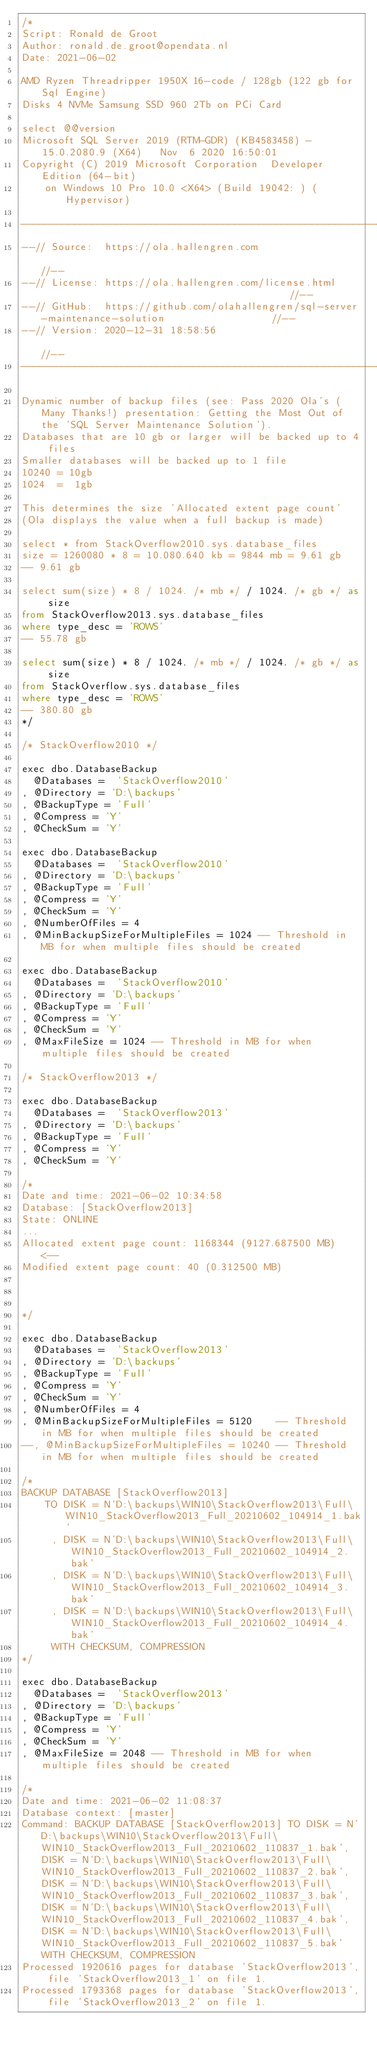Convert code to text. <code><loc_0><loc_0><loc_500><loc_500><_SQL_>/* 
Script: Ronald de Groot 
Author: ronald.de.groot@opendata.nl
Date: 2021-06-02

AMD Ryzen Threadripper 1950X 16-code / 128gb (122 gb for Sql Engine)
Disks 4 NVMe Samsung SSD 960 2Tb on PCi Card

select @@version
Microsoft SQL Server 2019 (RTM-GDR) (KB4583458) - 15.0.2080.9 (X64)   Nov  6 2020 16:50:01   
Copyright (C) 2019 Microsoft Corporation  Developer Edition (64-bit) 
	on Windows 10 Pro 10.0 <X64> (Build 19042: ) (Hypervisor) 

----------------------------------------------------------------------------------------------------
--// Source:  https://ola.hallengren.com                                                        //--
--// License: https://ola.hallengren.com/license.html                                           //--
--// GitHub:  https://github.com/olahallengren/sql-server-maintenance-solution                  //--
--// Version: 2020-12-31 18:58:56                                                               //--
----------------------------------------------------------------------------------------------------

Dynamic number of backup files (see: Pass 2020 Ola's (Many Thanks!) presentation: Getting the Most Out of the 'SQL Server Maintenance Solution').
Databases that are 10 gb or larger will be backed up to 4 files
Smaller databases will be backed up to 1 file
10240 = 10gb
1024  =  1gb

This determines the size 'Allocated extent page count'
(Ola displays the value when a full backup is made)

select * from StackOverflow2010.sys.database_files
size = 1260080 * 8 = 10.080.640 kb = 9844 mb = 9.61 gb
-- 9.61 gb

select sum(size) * 8 / 1024. /* mb */ / 1024. /* gb */ as size
from StackOverflow2013.sys.database_files
where type_desc = 'ROWS'
-- 55.78 gb

select sum(size) * 8 / 1024. /* mb */ / 1024. /* gb */ as size
from StackOverflow.sys.database_files
where type_desc = 'ROWS'
-- 380.80 gb
*/

/* StackOverflow2010 */

exec dbo.DatabaseBackup 
  @Databases =  'StackOverflow2010'
, @Directory = 'D:\backups'
, @BackupType = 'Full'
, @Compress = 'Y'
, @CheckSum = 'Y'

exec dbo.DatabaseBackup 
  @Databases =  'StackOverflow2010'
, @Directory = 'D:\backups'
, @BackupType = 'Full'
, @Compress = 'Y'
, @CheckSum = 'Y'
, @NumberOfFiles = 4
, @MinBackupSizeForMultipleFiles = 1024 -- Threshold in MB for when multiple files should be created

exec dbo.DatabaseBackup 
  @Databases =  'StackOverflow2010'
, @Directory = 'D:\backups'
, @BackupType = 'Full'
, @Compress = 'Y'
, @CheckSum = 'Y'
, @MaxFileSize = 1024 -- Threshold in MB for when multiple files should be created

/* StackOverflow2013 */

exec dbo.DatabaseBackup 
  @Databases =  'StackOverflow2013'
, @Directory = 'D:\backups'
, @BackupType = 'Full'
, @Compress = 'Y'
, @CheckSum = 'Y'

/*
Date and time: 2021-06-02 10:34:58
Database: [StackOverflow2013]
State: ONLINE
...
Allocated extent page count: 1168344 (9127.687500 MB)  <-- 
Modified extent page count: 40 (0.312500 MB)



*/

exec dbo.DatabaseBackup 
  @Databases =  'StackOverflow2013'
, @Directory = 'D:\backups'
, @BackupType = 'Full'
, @Compress = 'Y'
, @CheckSum = 'Y'
, @NumberOfFiles = 4
, @MinBackupSizeForMultipleFiles = 5120    -- Threshold in MB for when multiple files should be created
--, @MinBackupSizeForMultipleFiles = 10240 -- Threshold in MB for when multiple files should be created

/*
BACKUP DATABASE [StackOverflow2013] 
	TO DISK = N'D:\backups\WIN10\StackOverflow2013\Full\WIN10_StackOverflow2013_Full_20210602_104914_1.bak'
	 , DISK = N'D:\backups\WIN10\StackOverflow2013\Full\WIN10_StackOverflow2013_Full_20210602_104914_2.bak'
	 , DISK = N'D:\backups\WIN10\StackOverflow2013\Full\WIN10_StackOverflow2013_Full_20210602_104914_3.bak'
	 , DISK = N'D:\backups\WIN10\StackOverflow2013\Full\WIN10_StackOverflow2013_Full_20210602_104914_4.bak'
	 WITH CHECKSUM, COMPRESSION
*/

exec dbo.DatabaseBackup 
  @Databases =  'StackOverflow2013'
, @Directory = 'D:\backups'
, @BackupType = 'Full'
, @Compress = 'Y'
, @CheckSum = 'Y'
, @MaxFileSize = 2048 -- Threshold in MB for when multiple files should be created

/*
Date and time: 2021-06-02 11:08:37
Database context: [master]
Command: BACKUP DATABASE [StackOverflow2013] TO DISK = N'D:\backups\WIN10\StackOverflow2013\Full\WIN10_StackOverflow2013_Full_20210602_110837_1.bak', DISK = N'D:\backups\WIN10\StackOverflow2013\Full\WIN10_StackOverflow2013_Full_20210602_110837_2.bak', DISK = N'D:\backups\WIN10\StackOverflow2013\Full\WIN10_StackOverflow2013_Full_20210602_110837_3.bak', DISK = N'D:\backups\WIN10\StackOverflow2013\Full\WIN10_StackOverflow2013_Full_20210602_110837_4.bak', DISK = N'D:\backups\WIN10\StackOverflow2013\Full\WIN10_StackOverflow2013_Full_20210602_110837_5.bak' WITH CHECKSUM, COMPRESSION
Processed 1920616 pages for database 'StackOverflow2013', file 'StackOverflow2013_1' on file 1.
Processed 1793368 pages for database 'StackOverflow2013', file 'StackOverflow2013_2' on file 1.</code> 